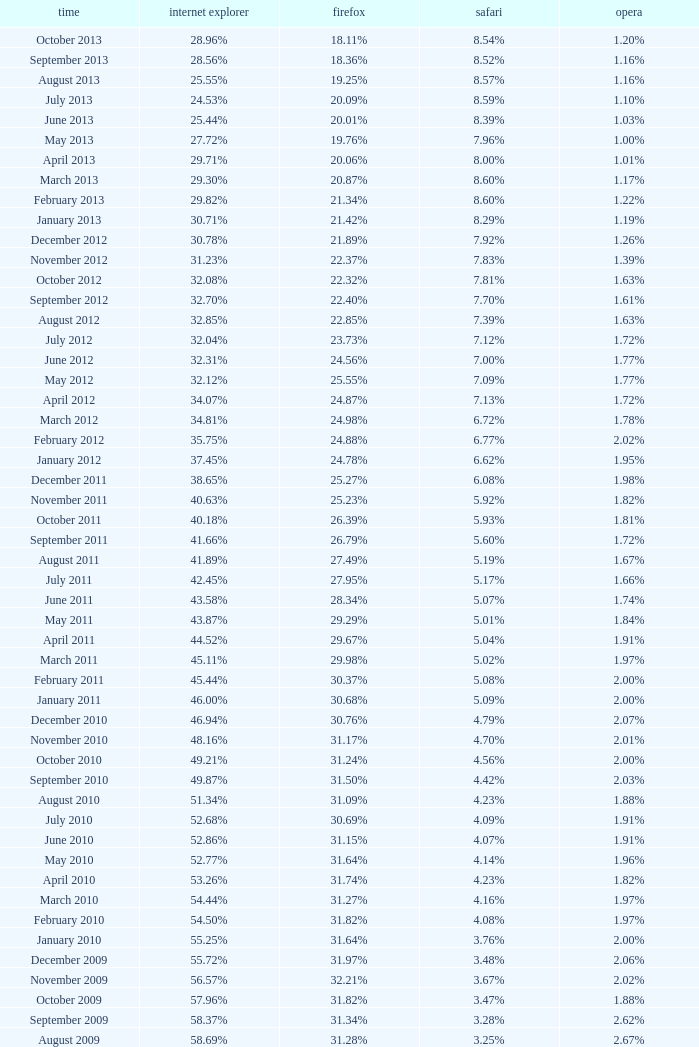What percentage of browsers were using Internet Explorer during the period in which 27.85% were using Firefox? 64.43%. 